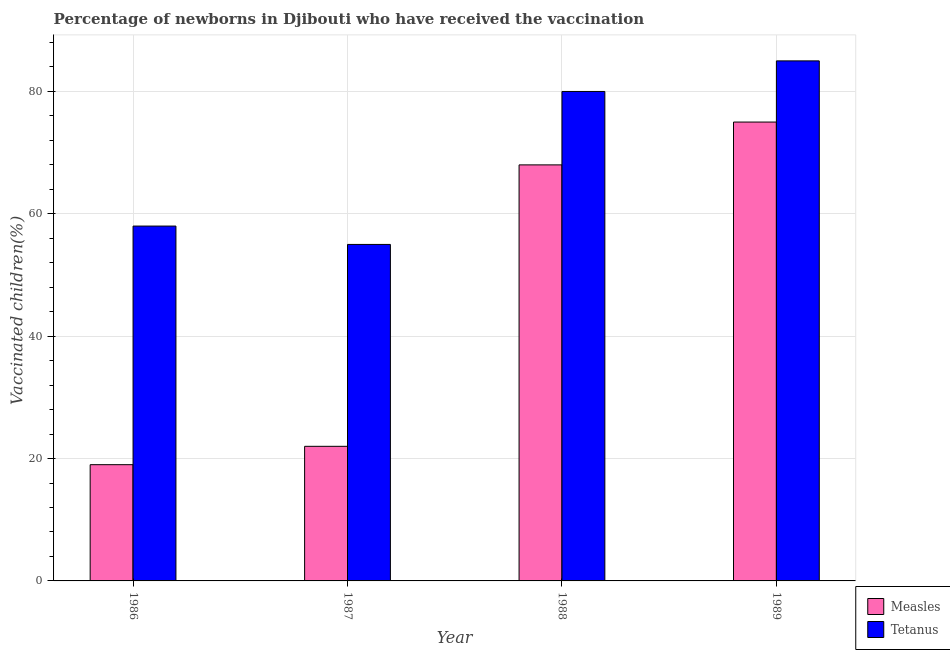Are the number of bars per tick equal to the number of legend labels?
Provide a short and direct response. Yes. How many bars are there on the 1st tick from the left?
Provide a succinct answer. 2. What is the label of the 3rd group of bars from the left?
Provide a short and direct response. 1988. In how many cases, is the number of bars for a given year not equal to the number of legend labels?
Ensure brevity in your answer.  0. What is the percentage of newborns who received vaccination for tetanus in 1986?
Offer a terse response. 58. Across all years, what is the maximum percentage of newborns who received vaccination for measles?
Your answer should be compact. 75. Across all years, what is the minimum percentage of newborns who received vaccination for tetanus?
Offer a terse response. 55. In which year was the percentage of newborns who received vaccination for tetanus maximum?
Give a very brief answer. 1989. In which year was the percentage of newborns who received vaccination for tetanus minimum?
Your answer should be very brief. 1987. What is the total percentage of newborns who received vaccination for measles in the graph?
Keep it short and to the point. 184. What is the difference between the percentage of newborns who received vaccination for tetanus in 1986 and that in 1989?
Make the answer very short. -27. What is the difference between the percentage of newborns who received vaccination for measles in 1988 and the percentage of newborns who received vaccination for tetanus in 1987?
Give a very brief answer. 46. What is the average percentage of newborns who received vaccination for tetanus per year?
Provide a succinct answer. 69.5. What is the ratio of the percentage of newborns who received vaccination for tetanus in 1986 to that in 1987?
Provide a short and direct response. 1.05. What is the difference between the highest and the lowest percentage of newborns who received vaccination for tetanus?
Give a very brief answer. 30. What does the 1st bar from the left in 1989 represents?
Provide a short and direct response. Measles. What does the 1st bar from the right in 1988 represents?
Your answer should be compact. Tetanus. How many bars are there?
Provide a short and direct response. 8. Are all the bars in the graph horizontal?
Provide a succinct answer. No. How many years are there in the graph?
Your response must be concise. 4. What is the difference between two consecutive major ticks on the Y-axis?
Give a very brief answer. 20. Are the values on the major ticks of Y-axis written in scientific E-notation?
Ensure brevity in your answer.  No. Does the graph contain any zero values?
Offer a terse response. No. Does the graph contain grids?
Your answer should be very brief. Yes. How many legend labels are there?
Offer a very short reply. 2. What is the title of the graph?
Give a very brief answer. Percentage of newborns in Djibouti who have received the vaccination. Does "Official creditors" appear as one of the legend labels in the graph?
Your response must be concise. No. What is the label or title of the Y-axis?
Keep it short and to the point. Vaccinated children(%)
. Across all years, what is the maximum Vaccinated children(%)
 in Measles?
Ensure brevity in your answer.  75. Across all years, what is the maximum Vaccinated children(%)
 of Tetanus?
Keep it short and to the point. 85. Across all years, what is the minimum Vaccinated children(%)
 in Measles?
Offer a terse response. 19. Across all years, what is the minimum Vaccinated children(%)
 in Tetanus?
Make the answer very short. 55. What is the total Vaccinated children(%)
 in Measles in the graph?
Your answer should be very brief. 184. What is the total Vaccinated children(%)
 in Tetanus in the graph?
Your response must be concise. 278. What is the difference between the Vaccinated children(%)
 of Measles in 1986 and that in 1988?
Provide a succinct answer. -49. What is the difference between the Vaccinated children(%)
 of Tetanus in 1986 and that in 1988?
Keep it short and to the point. -22. What is the difference between the Vaccinated children(%)
 of Measles in 1986 and that in 1989?
Your response must be concise. -56. What is the difference between the Vaccinated children(%)
 of Tetanus in 1986 and that in 1989?
Provide a succinct answer. -27. What is the difference between the Vaccinated children(%)
 in Measles in 1987 and that in 1988?
Provide a succinct answer. -46. What is the difference between the Vaccinated children(%)
 in Tetanus in 1987 and that in 1988?
Your answer should be compact. -25. What is the difference between the Vaccinated children(%)
 in Measles in 1987 and that in 1989?
Give a very brief answer. -53. What is the difference between the Vaccinated children(%)
 of Tetanus in 1988 and that in 1989?
Make the answer very short. -5. What is the difference between the Vaccinated children(%)
 in Measles in 1986 and the Vaccinated children(%)
 in Tetanus in 1987?
Make the answer very short. -36. What is the difference between the Vaccinated children(%)
 in Measles in 1986 and the Vaccinated children(%)
 in Tetanus in 1988?
Your answer should be compact. -61. What is the difference between the Vaccinated children(%)
 of Measles in 1986 and the Vaccinated children(%)
 of Tetanus in 1989?
Offer a very short reply. -66. What is the difference between the Vaccinated children(%)
 of Measles in 1987 and the Vaccinated children(%)
 of Tetanus in 1988?
Ensure brevity in your answer.  -58. What is the difference between the Vaccinated children(%)
 of Measles in 1987 and the Vaccinated children(%)
 of Tetanus in 1989?
Offer a very short reply. -63. What is the average Vaccinated children(%)
 in Measles per year?
Your answer should be very brief. 46. What is the average Vaccinated children(%)
 in Tetanus per year?
Offer a terse response. 69.5. In the year 1986, what is the difference between the Vaccinated children(%)
 in Measles and Vaccinated children(%)
 in Tetanus?
Provide a succinct answer. -39. In the year 1987, what is the difference between the Vaccinated children(%)
 in Measles and Vaccinated children(%)
 in Tetanus?
Provide a succinct answer. -33. What is the ratio of the Vaccinated children(%)
 in Measles in 1986 to that in 1987?
Your answer should be very brief. 0.86. What is the ratio of the Vaccinated children(%)
 in Tetanus in 1986 to that in 1987?
Give a very brief answer. 1.05. What is the ratio of the Vaccinated children(%)
 of Measles in 1986 to that in 1988?
Offer a very short reply. 0.28. What is the ratio of the Vaccinated children(%)
 of Tetanus in 1986 to that in 1988?
Your answer should be very brief. 0.72. What is the ratio of the Vaccinated children(%)
 of Measles in 1986 to that in 1989?
Give a very brief answer. 0.25. What is the ratio of the Vaccinated children(%)
 in Tetanus in 1986 to that in 1989?
Ensure brevity in your answer.  0.68. What is the ratio of the Vaccinated children(%)
 in Measles in 1987 to that in 1988?
Provide a short and direct response. 0.32. What is the ratio of the Vaccinated children(%)
 in Tetanus in 1987 to that in 1988?
Your answer should be very brief. 0.69. What is the ratio of the Vaccinated children(%)
 in Measles in 1987 to that in 1989?
Your response must be concise. 0.29. What is the ratio of the Vaccinated children(%)
 in Tetanus in 1987 to that in 1989?
Keep it short and to the point. 0.65. What is the ratio of the Vaccinated children(%)
 of Measles in 1988 to that in 1989?
Give a very brief answer. 0.91. What is the ratio of the Vaccinated children(%)
 of Tetanus in 1988 to that in 1989?
Your answer should be very brief. 0.94. What is the difference between the highest and the lowest Vaccinated children(%)
 in Measles?
Offer a very short reply. 56. 